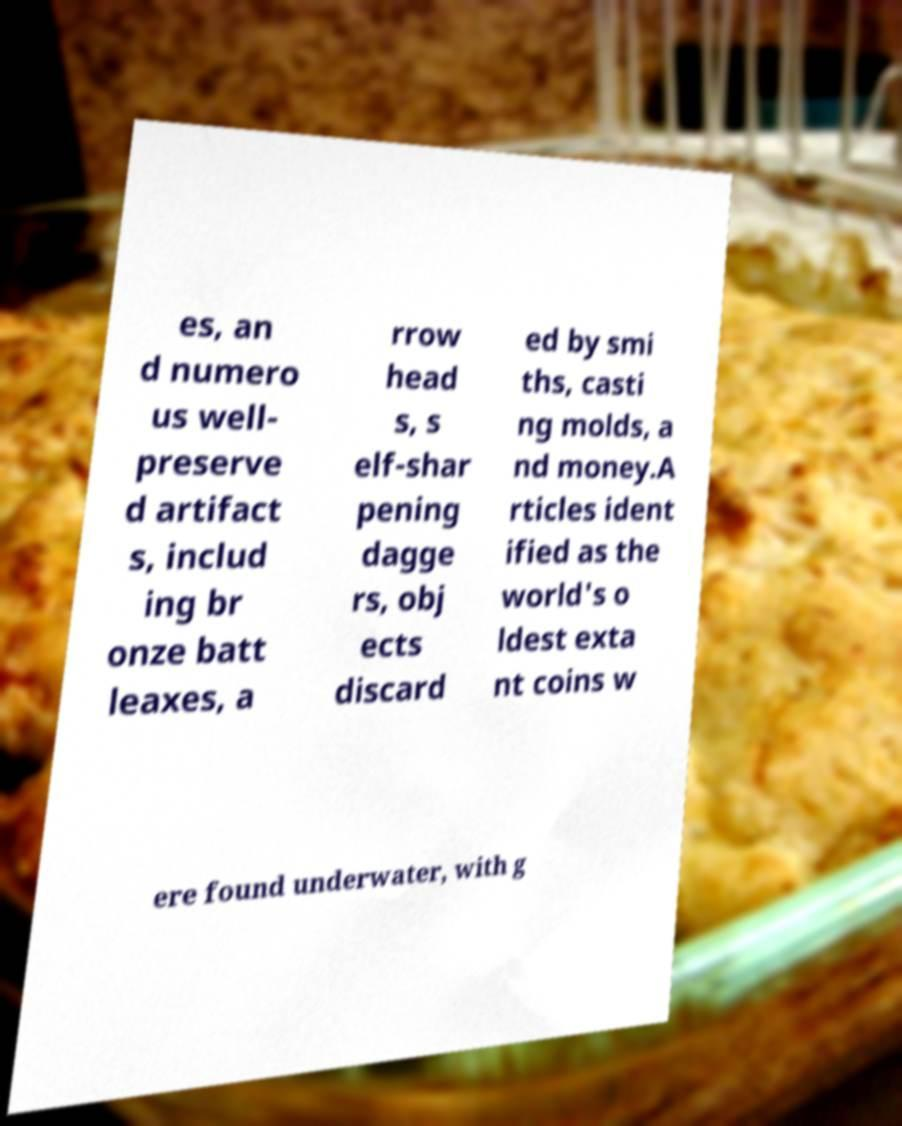Could you assist in decoding the text presented in this image and type it out clearly? es, an d numero us well- preserve d artifact s, includ ing br onze batt leaxes, a rrow head s, s elf-shar pening dagge rs, obj ects discard ed by smi ths, casti ng molds, a nd money.A rticles ident ified as the world's o ldest exta nt coins w ere found underwater, with g 